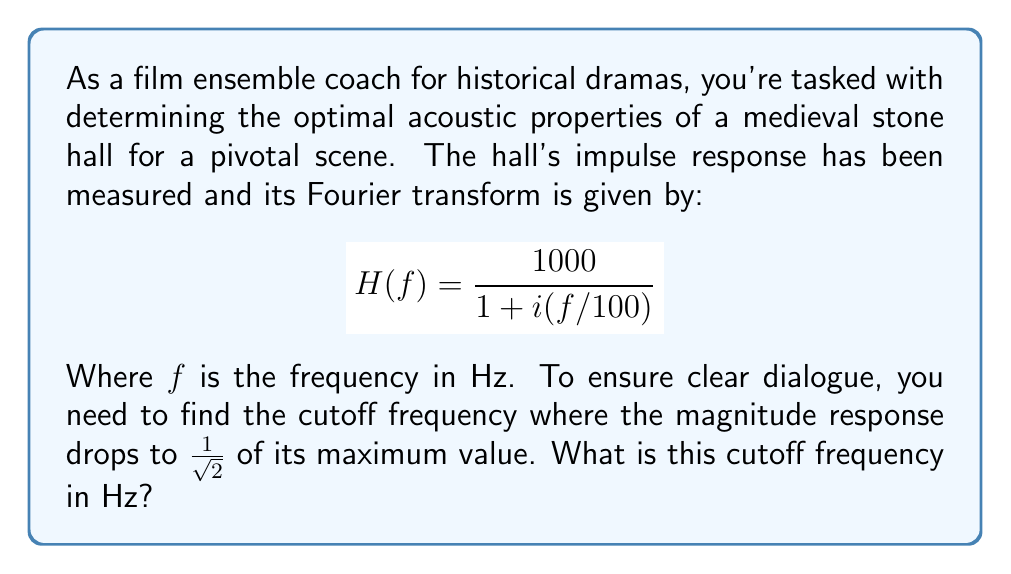Can you solve this math problem? To solve this problem, we'll follow these steps:

1) The magnitude response of the transfer function is given by:
   $$|H(f)| = \left|\frac{1000}{1 + i(f/100)}\right|$$

2) Using the property $|a+bi| = \sqrt{a^2 + b^2}$, we can simplify:
   $$|H(f)| = \frac{1000}{\sqrt{1^2 + (f/100)^2}} = \frac{1000}{\sqrt{1 + (f/100)^2}}$$

3) The maximum value occurs at $f=0$:
   $$|H(0)| = 1000$$

4) We need to find $f$ where $|H(f)| = \frac{1000}{\sqrt{2}}$:
   $$\frac{1000}{\sqrt{1 + (f/100)^2}} = \frac{1000}{\sqrt{2}}$$

5) Simplify:
   $$\sqrt{1 + (f/100)^2} = \sqrt{2}$$

6) Square both sides:
   $$1 + (f/100)^2 = 2$$

7) Solve for $f$:
   $$(f/100)^2 = 1$$
   $$f/100 = 1$$
   $$f = 100$$

Therefore, the cutoff frequency is 100 Hz.
Answer: 100 Hz 